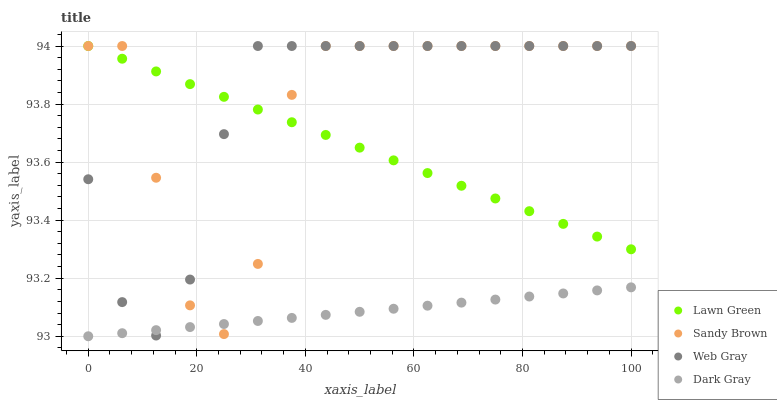Does Dark Gray have the minimum area under the curve?
Answer yes or no. Yes. Does Web Gray have the maximum area under the curve?
Answer yes or no. Yes. Does Lawn Green have the minimum area under the curve?
Answer yes or no. No. Does Lawn Green have the maximum area under the curve?
Answer yes or no. No. Is Dark Gray the smoothest?
Answer yes or no. Yes. Is Sandy Brown the roughest?
Answer yes or no. Yes. Is Lawn Green the smoothest?
Answer yes or no. No. Is Lawn Green the roughest?
Answer yes or no. No. Does Dark Gray have the lowest value?
Answer yes or no. Yes. Does Web Gray have the lowest value?
Answer yes or no. No. Does Sandy Brown have the highest value?
Answer yes or no. Yes. Is Dark Gray less than Lawn Green?
Answer yes or no. Yes. Is Lawn Green greater than Dark Gray?
Answer yes or no. Yes. Does Dark Gray intersect Sandy Brown?
Answer yes or no. Yes. Is Dark Gray less than Sandy Brown?
Answer yes or no. No. Is Dark Gray greater than Sandy Brown?
Answer yes or no. No. Does Dark Gray intersect Lawn Green?
Answer yes or no. No. 